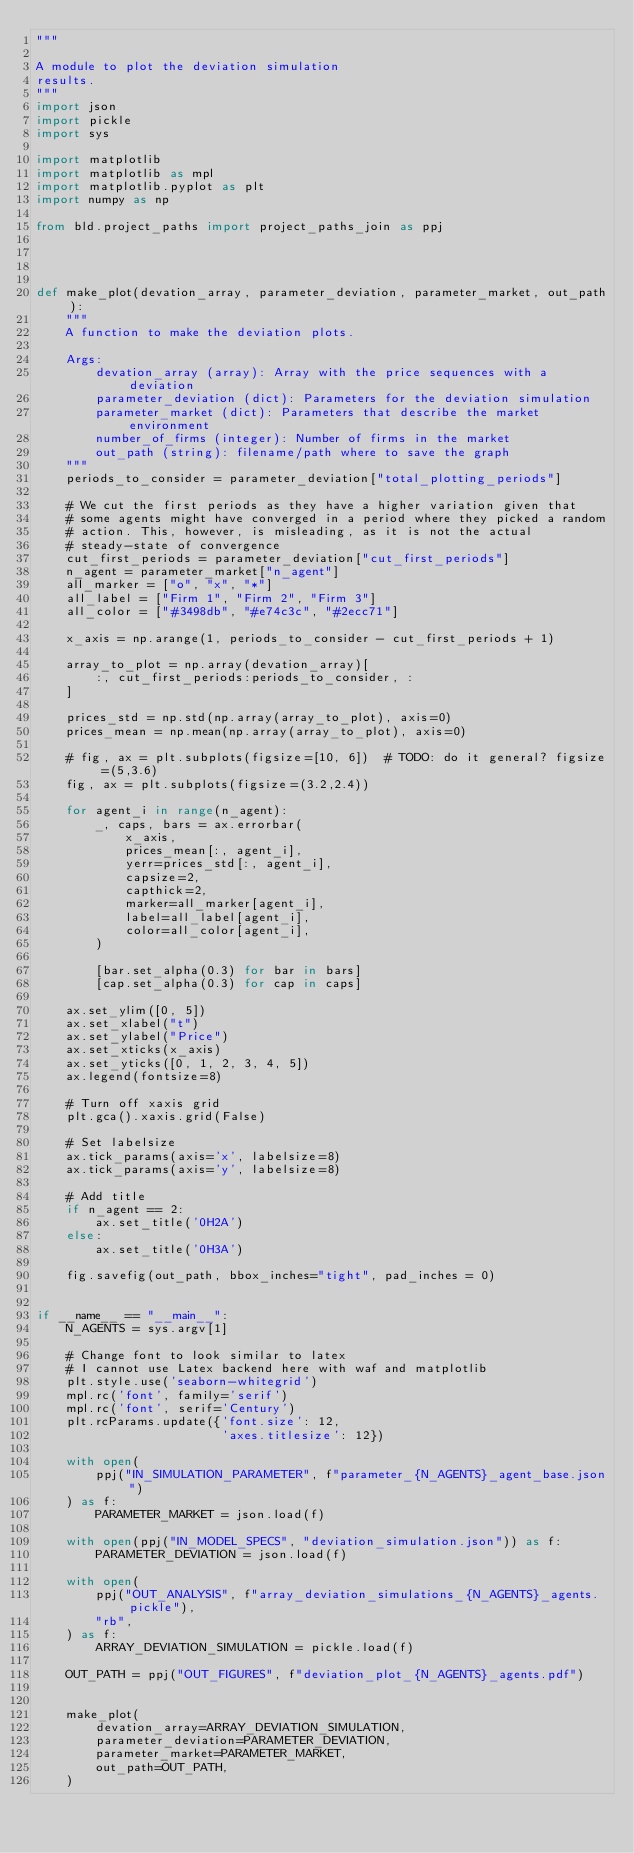<code> <loc_0><loc_0><loc_500><loc_500><_Python_>"""

A module to plot the deviation simulation
results.
"""
import json
import pickle
import sys

import matplotlib
import matplotlib as mpl
import matplotlib.pyplot as plt
import numpy as np

from bld.project_paths import project_paths_join as ppj




def make_plot(devation_array, parameter_deviation, parameter_market, out_path):
    """
    A function to make the deviation plots.

    Args:
        devation_array (array): Array with the price sequences with a deviation
        parameter_deviation (dict): Parameters for the deviation simulation
        parameter_market (dict): Parameters that describe the market environment
        number_of_firms (integer): Number of firms in the market
        out_path (string): filename/path where to save the graph
    """
    periods_to_consider = parameter_deviation["total_plotting_periods"]

    # We cut the first periods as they have a higher variation given that
    # some agents might have converged in a period where they picked a random
    # action. This, however, is misleading, as it is not the actual
    # steady-state of convergence
    cut_first_periods = parameter_deviation["cut_first_periods"]
    n_agent = parameter_market["n_agent"]
    all_marker = ["o", "x", "*"]
    all_label = ["Firm 1", "Firm 2", "Firm 3"]
    all_color = ["#3498db", "#e74c3c", "#2ecc71"]

    x_axis = np.arange(1, periods_to_consider - cut_first_periods + 1)

    array_to_plot = np.array(devation_array)[
        :, cut_first_periods:periods_to_consider, :
    ]

    prices_std = np.std(np.array(array_to_plot), axis=0)
    prices_mean = np.mean(np.array(array_to_plot), axis=0)

    # fig, ax = plt.subplots(figsize=[10, 6])  # TODO: do it general? figsize=(5,3.6)
    fig, ax = plt.subplots(figsize=(3.2,2.4))

    for agent_i in range(n_agent):
        _, caps, bars = ax.errorbar(
            x_axis,
            prices_mean[:, agent_i],
            yerr=prices_std[:, agent_i],
            capsize=2,
            capthick=2,
            marker=all_marker[agent_i],
            label=all_label[agent_i],
            color=all_color[agent_i],
        )

        [bar.set_alpha(0.3) for bar in bars]
        [cap.set_alpha(0.3) for cap in caps]

    ax.set_ylim([0, 5])
    ax.set_xlabel("t")
    ax.set_ylabel("Price")
    ax.set_xticks(x_axis)
    ax.set_yticks([0, 1, 2, 3, 4, 5])
    ax.legend(fontsize=8)
    
    # Turn off xaxis grid
    plt.gca().xaxis.grid(False)

    # Set labelsize
    ax.tick_params(axis='x', labelsize=8)
    ax.tick_params(axis='y', labelsize=8) 

    # Add title
    if n_agent == 2:
        ax.set_title('0H2A')
    else:
        ax.set_title('0H3A')

    fig.savefig(out_path, bbox_inches="tight", pad_inches = 0)


if __name__ == "__main__":
    N_AGENTS = sys.argv[1]
   
    # Change font to look similar to latex
    # I cannot use Latex backend here with waf and matplotlib
    plt.style.use('seaborn-whitegrid')
    mpl.rc('font', family='serif') 
    mpl.rc('font', serif='Century') 
    plt.rcParams.update({'font.size': 12,
                         'axes.titlesize': 12})    

    with open(
        ppj("IN_SIMULATION_PARAMETER", f"parameter_{N_AGENTS}_agent_base.json")
    ) as f:
        PARAMETER_MARKET = json.load(f)

    with open(ppj("IN_MODEL_SPECS", "deviation_simulation.json")) as f:
        PARAMETER_DEVIATION = json.load(f)

    with open(
        ppj("OUT_ANALYSIS", f"array_deviation_simulations_{N_AGENTS}_agents.pickle"),
        "rb",
    ) as f:
        ARRAY_DEVIATION_SIMULATION = pickle.load(f)

    OUT_PATH = ppj("OUT_FIGURES", f"deviation_plot_{N_AGENTS}_agents.pdf")


    make_plot(
        devation_array=ARRAY_DEVIATION_SIMULATION,
        parameter_deviation=PARAMETER_DEVIATION,
        parameter_market=PARAMETER_MARKET,
        out_path=OUT_PATH,
    )
</code> 